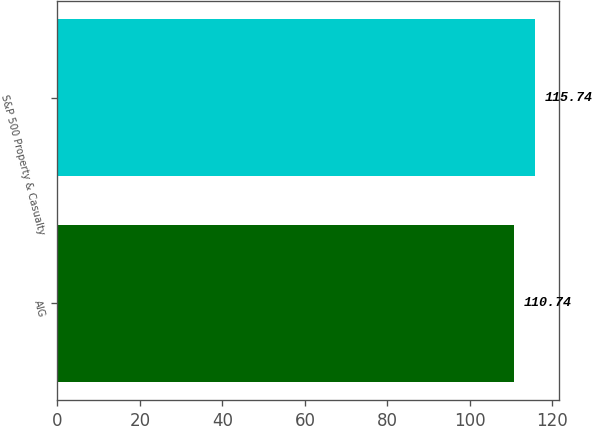Convert chart. <chart><loc_0><loc_0><loc_500><loc_500><bar_chart><fcel>AIG<fcel>S&P 500 Property & Casualty<nl><fcel>110.74<fcel>115.74<nl></chart> 